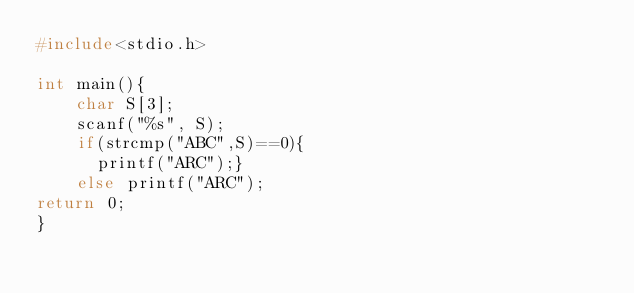Convert code to text. <code><loc_0><loc_0><loc_500><loc_500><_C_>#include<stdio.h>

int main(){
    char S[3];
    scanf("%s", S);
    if(strcmp("ABC",S)==0){
      printf("ARC");}
    else printf("ARC");
return 0;
}</code> 